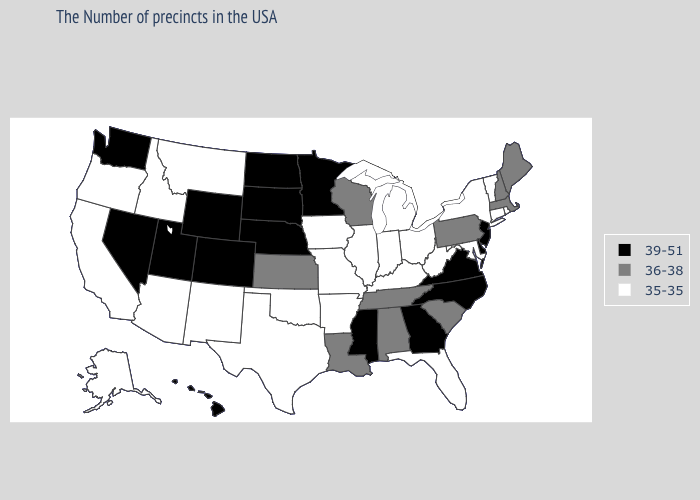Among the states that border Arizona , which have the lowest value?
Short answer required. New Mexico, California. Name the states that have a value in the range 36-38?
Answer briefly. Maine, Massachusetts, New Hampshire, Pennsylvania, South Carolina, Alabama, Tennessee, Wisconsin, Louisiana, Kansas. Name the states that have a value in the range 36-38?
Write a very short answer. Maine, Massachusetts, New Hampshire, Pennsylvania, South Carolina, Alabama, Tennessee, Wisconsin, Louisiana, Kansas. Among the states that border New Jersey , does Pennsylvania have the highest value?
Write a very short answer. No. Which states hav the highest value in the Northeast?
Write a very short answer. New Jersey. What is the highest value in states that border Louisiana?
Quick response, please. 39-51. Name the states that have a value in the range 36-38?
Quick response, please. Maine, Massachusetts, New Hampshire, Pennsylvania, South Carolina, Alabama, Tennessee, Wisconsin, Louisiana, Kansas. What is the value of Mississippi?
Keep it brief. 39-51. Does Connecticut have a higher value than Vermont?
Be succinct. No. What is the value of North Carolina?
Concise answer only. 39-51. Which states have the highest value in the USA?
Answer briefly. New Jersey, Delaware, Virginia, North Carolina, Georgia, Mississippi, Minnesota, Nebraska, South Dakota, North Dakota, Wyoming, Colorado, Utah, Nevada, Washington, Hawaii. Among the states that border North Carolina , which have the lowest value?
Give a very brief answer. South Carolina, Tennessee. Which states have the highest value in the USA?
Give a very brief answer. New Jersey, Delaware, Virginia, North Carolina, Georgia, Mississippi, Minnesota, Nebraska, South Dakota, North Dakota, Wyoming, Colorado, Utah, Nevada, Washington, Hawaii. Name the states that have a value in the range 35-35?
Give a very brief answer. Rhode Island, Vermont, Connecticut, New York, Maryland, West Virginia, Ohio, Florida, Michigan, Kentucky, Indiana, Illinois, Missouri, Arkansas, Iowa, Oklahoma, Texas, New Mexico, Montana, Arizona, Idaho, California, Oregon, Alaska. 